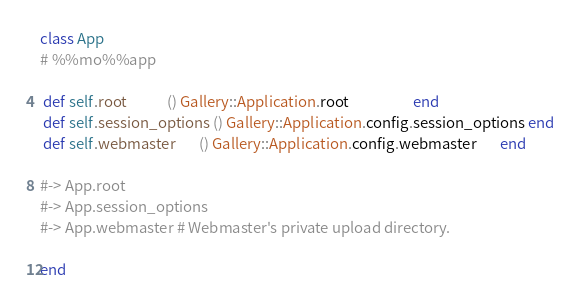Convert code to text. <code><loc_0><loc_0><loc_500><loc_500><_Ruby_>class App
# %%mo%%app

 def self.root            () Gallery::Application.root                   end
 def self.session_options () Gallery::Application.config.session_options end
 def self.webmaster       () Gallery::Application.config.webmaster       end

#-> App.root
#-> App.session_options
#-> App.webmaster # Webmaster's private upload directory.

end
</code> 